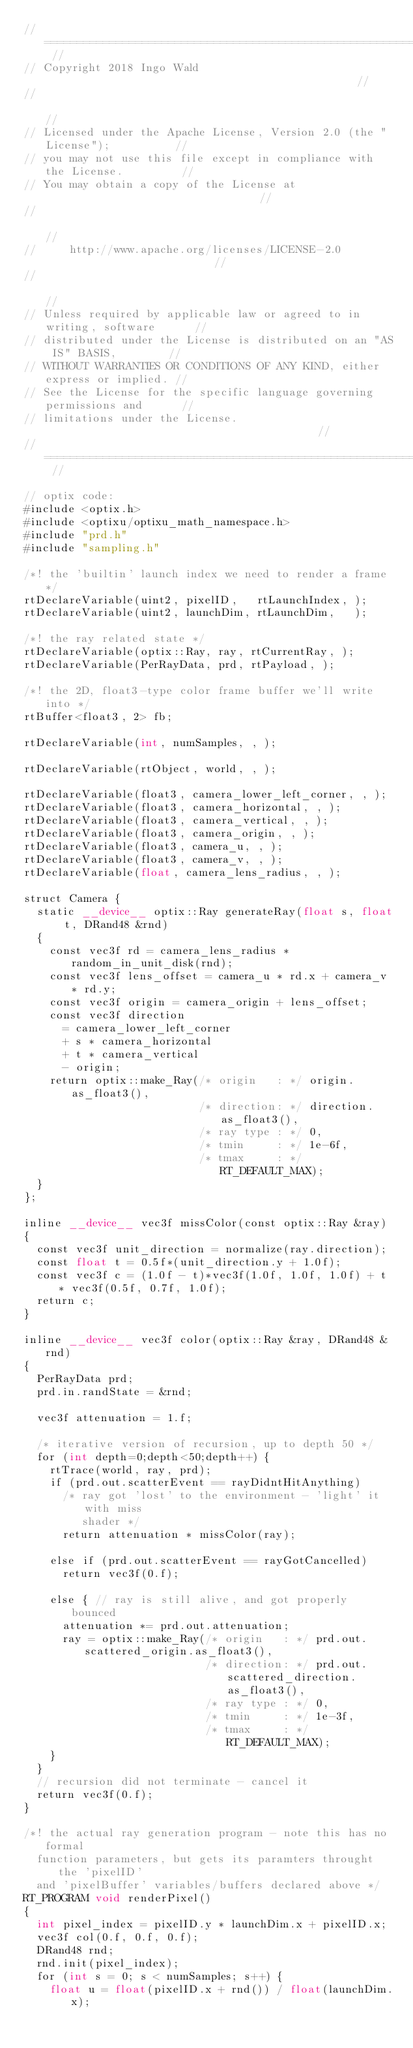<code> <loc_0><loc_0><loc_500><loc_500><_Cuda_>// ======================================================================== //
// Copyright 2018 Ingo Wald                                                 //
//                                                                          //
// Licensed under the Apache License, Version 2.0 (the "License");          //
// you may not use this file except in compliance with the License.         //
// You may obtain a copy of the License at                                  //
//                                                                          //
//     http://www.apache.org/licenses/LICENSE-2.0                           //
//                                                                          //
// Unless required by applicable law or agreed to in writing, software      //
// distributed under the License is distributed on an "AS IS" BASIS,        //
// WITHOUT WARRANTIES OR CONDITIONS OF ANY KIND, either express or implied. //
// See the License for the specific language governing permissions and      //
// limitations under the License.                                           //
// ======================================================================== //

// optix code:
#include <optix.h>
#include <optixu/optixu_math_namespace.h>
#include "prd.h"
#include "sampling.h"

/*! the 'builtin' launch index we need to render a frame */
rtDeclareVariable(uint2, pixelID,   rtLaunchIndex, );
rtDeclareVariable(uint2, launchDim, rtLaunchDim,   );

/*! the ray related state */
rtDeclareVariable(optix::Ray, ray, rtCurrentRay, );
rtDeclareVariable(PerRayData, prd, rtPayload, );

/*! the 2D, float3-type color frame buffer we'll write into */
rtBuffer<float3, 2> fb;

rtDeclareVariable(int, numSamples, , );

rtDeclareVariable(rtObject, world, , );

rtDeclareVariable(float3, camera_lower_left_corner, , );
rtDeclareVariable(float3, camera_horizontal, , );
rtDeclareVariable(float3, camera_vertical, , );
rtDeclareVariable(float3, camera_origin, , );
rtDeclareVariable(float3, camera_u, , );
rtDeclareVariable(float3, camera_v, , );
rtDeclareVariable(float, camera_lens_radius, , );

struct Camera {
  static __device__ optix::Ray generateRay(float s, float t, DRand48 &rnd) 
  {
    const vec3f rd = camera_lens_radius * random_in_unit_disk(rnd);
    const vec3f lens_offset = camera_u * rd.x + camera_v * rd.y;
    const vec3f origin = camera_origin + lens_offset;
    const vec3f direction
      = camera_lower_left_corner
      + s * camera_horizontal
      + t * camera_vertical
      - origin;
    return optix::make_Ray(/* origin   : */ origin.as_float3(),
                           /* direction: */ direction.as_float3(),
                           /* ray type : */ 0,
                           /* tmin     : */ 1e-6f,
                           /* tmax     : */ RT_DEFAULT_MAX);
  }
};

inline __device__ vec3f missColor(const optix::Ray &ray)
{
  const vec3f unit_direction = normalize(ray.direction);
  const float t = 0.5f*(unit_direction.y + 1.0f);
  const vec3f c = (1.0f - t)*vec3f(1.0f, 1.0f, 1.0f) + t * vec3f(0.5f, 0.7f, 1.0f);
  return c;
}

inline __device__ vec3f color(optix::Ray &ray, DRand48 &rnd)
{
  PerRayData prd;
  prd.in.randState = &rnd;

  vec3f attenuation = 1.f;
  
  /* iterative version of recursion, up to depth 50 */
  for (int depth=0;depth<50;depth++) {
    rtTrace(world, ray, prd);
    if (prd.out.scatterEvent == rayDidntHitAnything)
      /* ray got 'lost' to the environment - 'light' it with miss
         shader */
      return attenuation * missColor(ray);

    else if (prd.out.scatterEvent == rayGotCancelled)
      return vec3f(0.f);

    else { // ray is still alive, and got properly bounced
      attenuation *= prd.out.attenuation;
      ray = optix::make_Ray(/* origin   : */ prd.out.scattered_origin.as_float3(),
                            /* direction: */ prd.out.scattered_direction.as_float3(),
                            /* ray type : */ 0,
                            /* tmin     : */ 1e-3f,
                            /* tmax     : */ RT_DEFAULT_MAX);
    }
  }
  // recursion did not terminate - cancel it
  return vec3f(0.f);
}

/*! the actual ray generation program - note this has no formal
  function parameters, but gets its paramters throught the 'pixelID'
  and 'pixelBuffer' variables/buffers declared above */
RT_PROGRAM void renderPixel()
{
  int pixel_index = pixelID.y * launchDim.x + pixelID.x;
  vec3f col(0.f, 0.f, 0.f);
  DRand48 rnd;
  rnd.init(pixel_index);
  for (int s = 0; s < numSamples; s++) {
    float u = float(pixelID.x + rnd()) / float(launchDim.x);</code> 